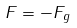Convert formula to latex. <formula><loc_0><loc_0><loc_500><loc_500>F = - F _ { g }</formula> 